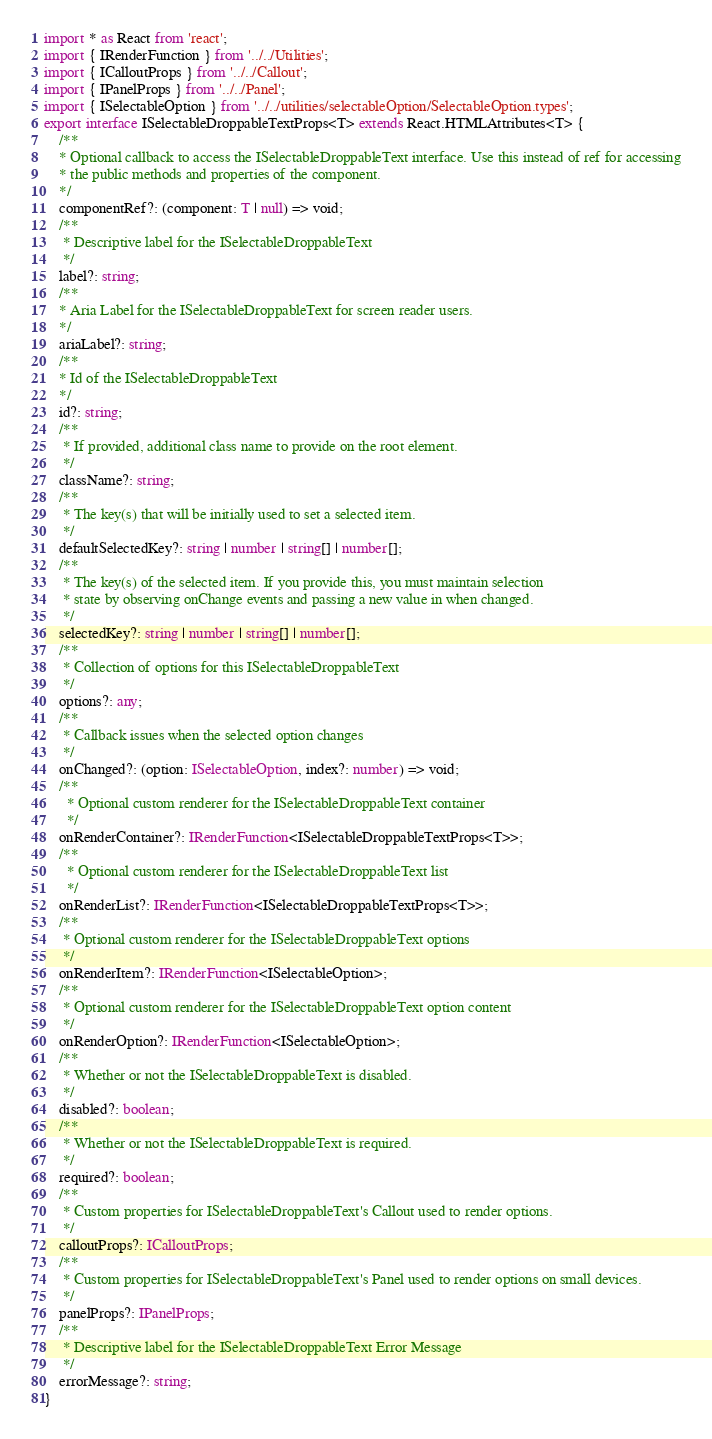<code> <loc_0><loc_0><loc_500><loc_500><_TypeScript_>import * as React from 'react';
import { IRenderFunction } from '../../Utilities';
import { ICalloutProps } from '../../Callout';
import { IPanelProps } from '../../Panel';
import { ISelectableOption } from '../../utilities/selectableOption/SelectableOption.types';
export interface ISelectableDroppableTextProps<T> extends React.HTMLAttributes<T> {
    /**
    * Optional callback to access the ISelectableDroppableText interface. Use this instead of ref for accessing
    * the public methods and properties of the component.
    */
    componentRef?: (component: T | null) => void;
    /**
     * Descriptive label for the ISelectableDroppableText
     */
    label?: string;
    /**
    * Aria Label for the ISelectableDroppableText for screen reader users.
    */
    ariaLabel?: string;
    /**
    * Id of the ISelectableDroppableText
    */
    id?: string;
    /**
     * If provided, additional class name to provide on the root element.
     */
    className?: string;
    /**
     * The key(s) that will be initially used to set a selected item.
     */
    defaultSelectedKey?: string | number | string[] | number[];
    /**
     * The key(s) of the selected item. If you provide this, you must maintain selection
     * state by observing onChange events and passing a new value in when changed.
     */
    selectedKey?: string | number | string[] | number[];
    /**
     * Collection of options for this ISelectableDroppableText
     */
    options?: any;
    /**
     * Callback issues when the selected option changes
     */
    onChanged?: (option: ISelectableOption, index?: number) => void;
    /**
      * Optional custom renderer for the ISelectableDroppableText container
      */
    onRenderContainer?: IRenderFunction<ISelectableDroppableTextProps<T>>;
    /**
      * Optional custom renderer for the ISelectableDroppableText list
      */
    onRenderList?: IRenderFunction<ISelectableDroppableTextProps<T>>;
    /**
     * Optional custom renderer for the ISelectableDroppableText options
     */
    onRenderItem?: IRenderFunction<ISelectableOption>;
    /**
     * Optional custom renderer for the ISelectableDroppableText option content
     */
    onRenderOption?: IRenderFunction<ISelectableOption>;
    /**
     * Whether or not the ISelectableDroppableText is disabled.
     */
    disabled?: boolean;
    /**
     * Whether or not the ISelectableDroppableText is required.
     */
    required?: boolean;
    /**
     * Custom properties for ISelectableDroppableText's Callout used to render options.
     */
    calloutProps?: ICalloutProps;
    /**
     * Custom properties for ISelectableDroppableText's Panel used to render options on small devices.
     */
    panelProps?: IPanelProps;
    /**
     * Descriptive label for the ISelectableDroppableText Error Message
     */
    errorMessage?: string;
}
</code> 